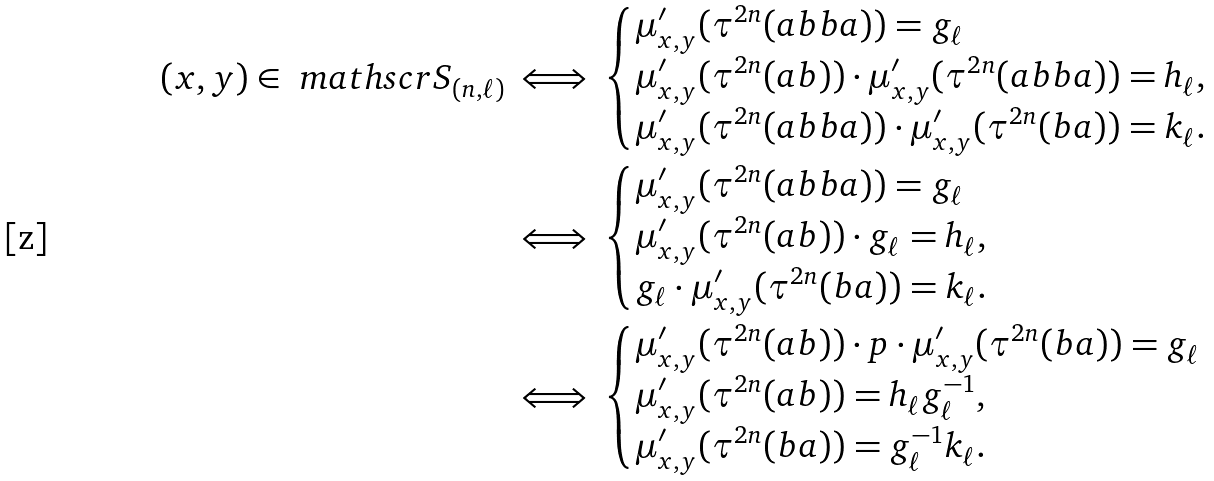Convert formula to latex. <formula><loc_0><loc_0><loc_500><loc_500>( x , y ) \in \ m a t h s c r S _ { ( n , \ell ) } & \iff \begin{cases} \mu _ { x , y } ^ { \prime } ( \tau ^ { 2 n } ( a b b a ) ) = g _ { \ell } \\ \mu _ { x , y } ^ { \prime } ( \tau ^ { 2 n } ( a b ) ) \cdot \mu _ { x , y } ^ { \prime } ( \tau ^ { 2 n } ( a b b a ) ) = h _ { \ell } , \\ \mu _ { x , y } ^ { \prime } ( \tau ^ { 2 n } ( a b b a ) ) \cdot \mu _ { x , y } ^ { \prime } ( \tau ^ { 2 n } ( b a ) ) = k _ { \ell } . \end{cases} \\ & \iff \begin{cases} \mu _ { x , y } ^ { \prime } ( \tau ^ { 2 n } ( a b b a ) ) = g _ { \ell } \\ \mu _ { x , y } ^ { \prime } ( \tau ^ { 2 n } ( a b ) ) \cdot g _ { \ell } = h _ { \ell } , \\ g _ { \ell } \cdot \mu _ { x , y } ^ { \prime } ( \tau ^ { 2 n } ( b a ) ) = k _ { \ell } . \end{cases} \\ & \iff \begin{cases} \mu _ { x , y } ^ { \prime } ( \tau ^ { 2 n } ( a b ) ) \cdot p \cdot \mu _ { x , y } ^ { \prime } ( \tau ^ { 2 n } ( b a ) ) = g _ { \ell } \\ \mu _ { x , y } ^ { \prime } ( \tau ^ { 2 n } ( a b ) ) = h _ { \ell } g _ { \ell } ^ { - 1 } , \\ \mu _ { x , y } ^ { \prime } ( \tau ^ { 2 n } ( b a ) ) = g _ { \ell } ^ { - 1 } k _ { \ell } . \end{cases}</formula> 